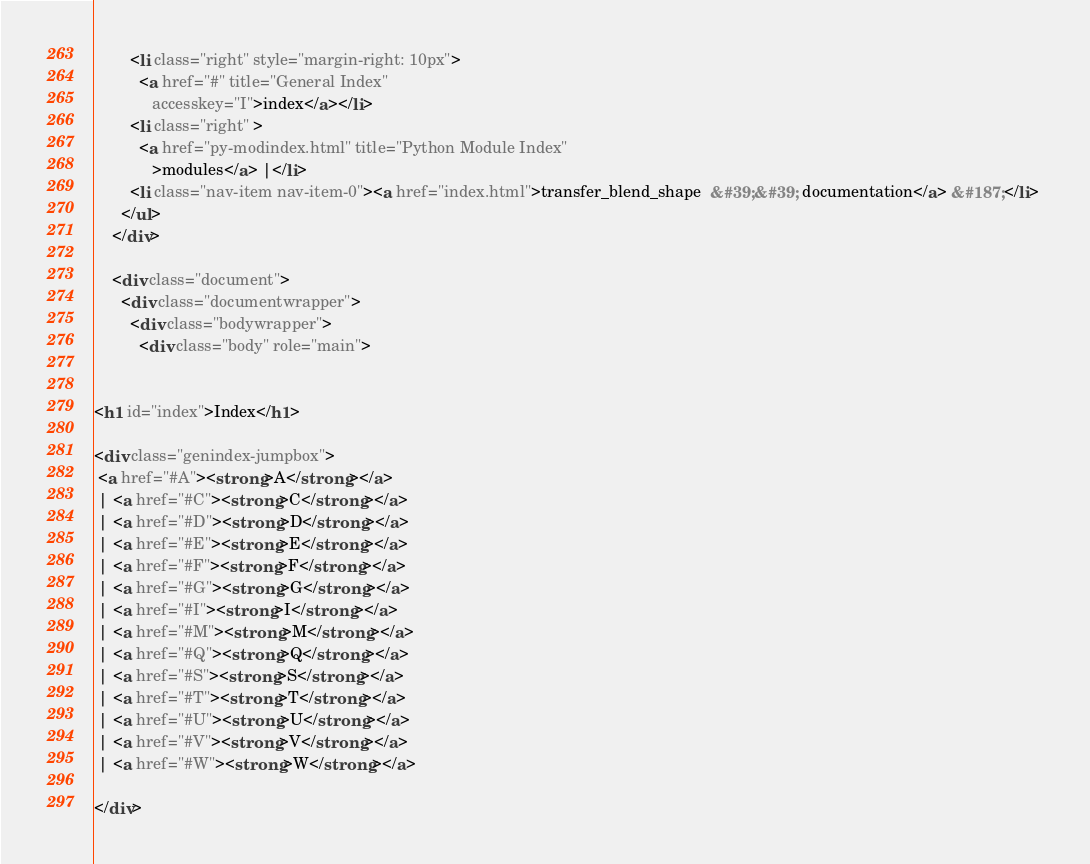<code> <loc_0><loc_0><loc_500><loc_500><_HTML_>        <li class="right" style="margin-right: 10px">
          <a href="#" title="General Index"
             accesskey="I">index</a></li>
        <li class="right" >
          <a href="py-modindex.html" title="Python Module Index"
             >modules</a> |</li>
        <li class="nav-item nav-item-0"><a href="index.html">transfer_blend_shape  &#39;&#39; documentation</a> &#187;</li> 
      </ul>
    </div>  

    <div class="document">
      <div class="documentwrapper">
        <div class="bodywrapper">
          <div class="body" role="main">
            

<h1 id="index">Index</h1>

<div class="genindex-jumpbox">
 <a href="#A"><strong>A</strong></a>
 | <a href="#C"><strong>C</strong></a>
 | <a href="#D"><strong>D</strong></a>
 | <a href="#E"><strong>E</strong></a>
 | <a href="#F"><strong>F</strong></a>
 | <a href="#G"><strong>G</strong></a>
 | <a href="#I"><strong>I</strong></a>
 | <a href="#M"><strong>M</strong></a>
 | <a href="#Q"><strong>Q</strong></a>
 | <a href="#S"><strong>S</strong></a>
 | <a href="#T"><strong>T</strong></a>
 | <a href="#U"><strong>U</strong></a>
 | <a href="#V"><strong>V</strong></a>
 | <a href="#W"><strong>W</strong></a>
 
</div></code> 